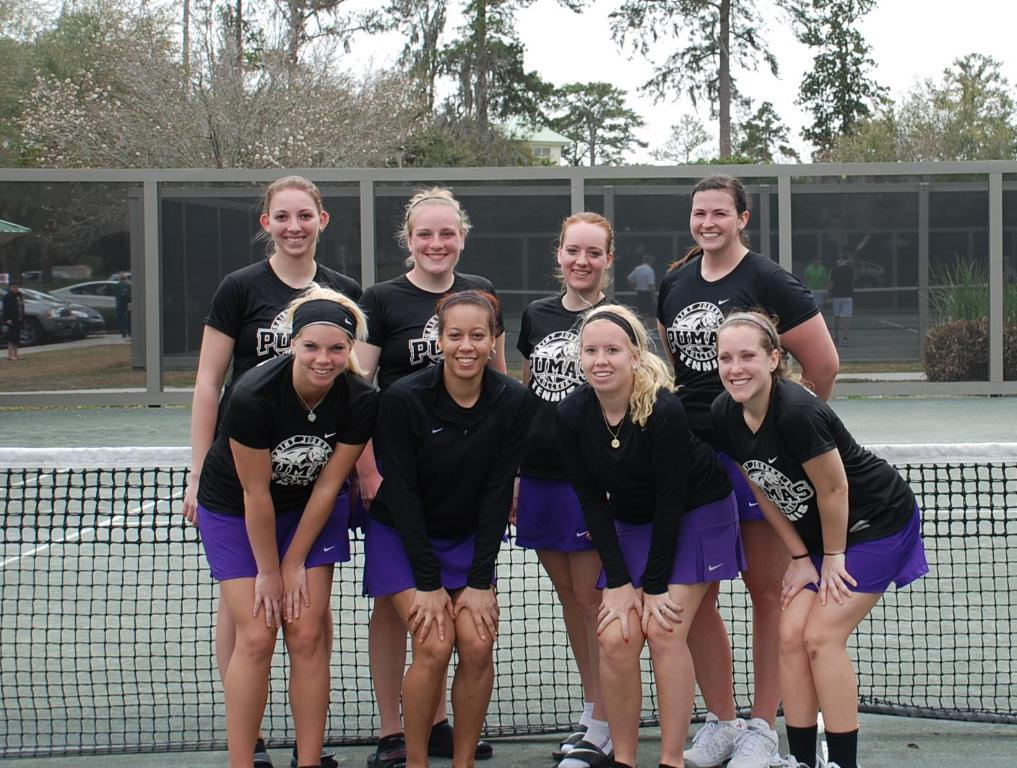What can be seen in the image? There are people standing in the image. What is at the bottom of the image? There is a net at the bottom of the image. What is visible in the background of the image? There are trees and sky visible in the background of the image. What type of barrier is present in the image? There is a fence in the image. What else is present in the image besides people and the fence? Cars are present in the image. What type of letters can be seen on the farmer's shirt in the image? There is no farmer or shirt with letters present in the image. 